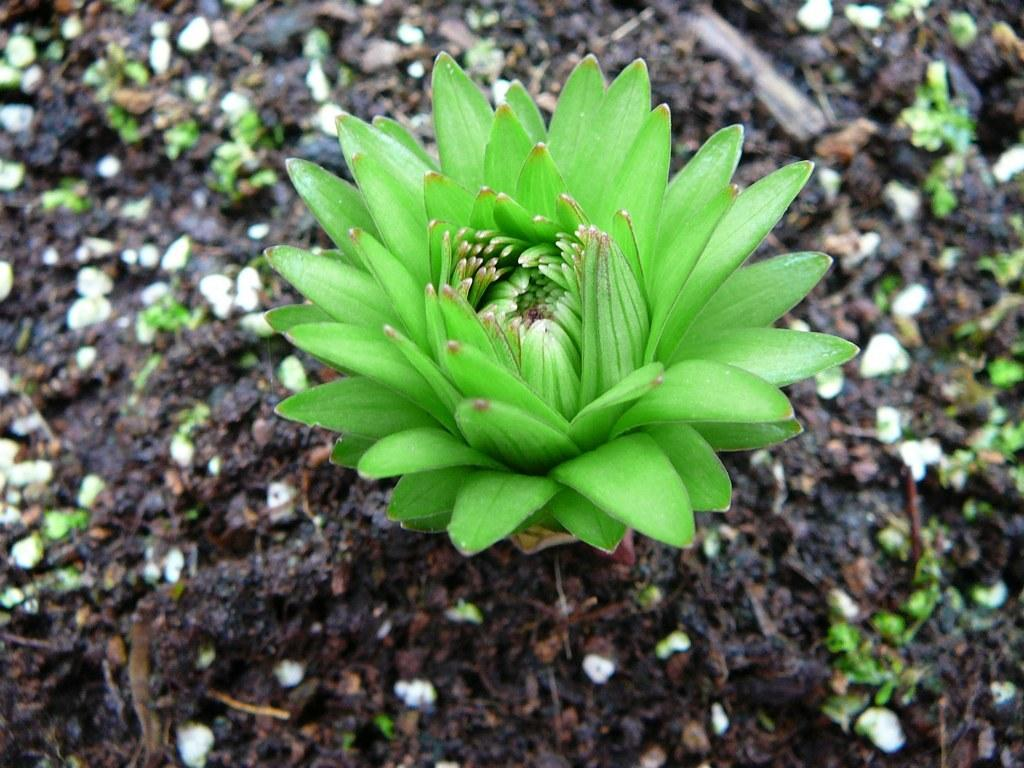What type of flower can be seen in the image? There is a green color flower in the image. Where is the flower located in the image? The flower is on the ground. What else can be found on the ground in the image? There are other plants on the ground. Can you describe the background of the image? The background of the image is blurred. What type of cord is used to hold the ink in the image? There is no cord or ink present in the image; it features a green color flower on the ground with other plants and a blurred background. 